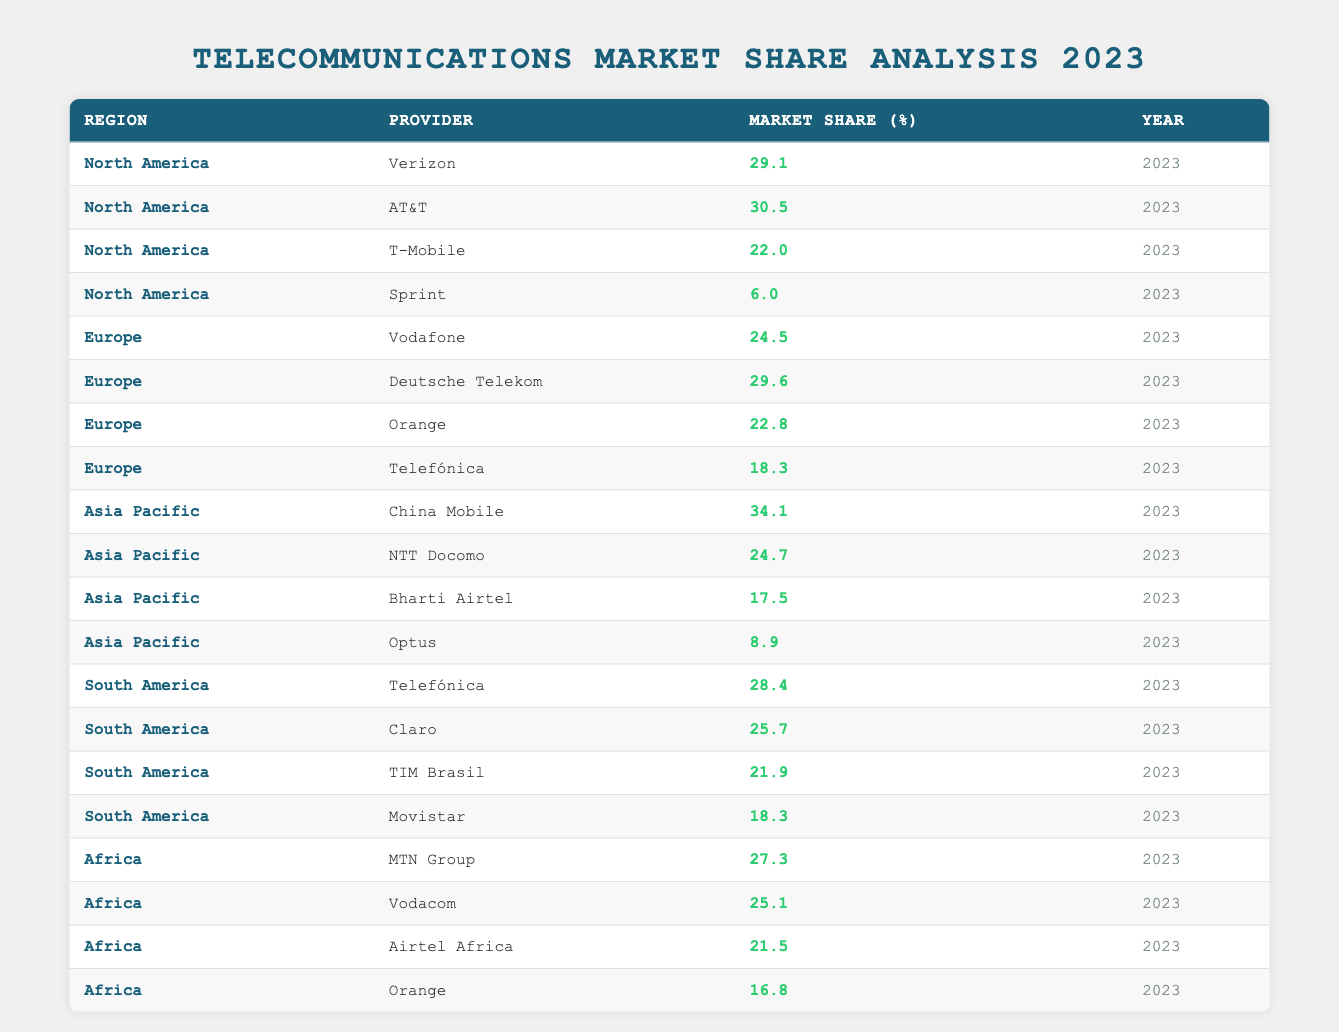What is the market share percentage of AT&T in North America? The table lists AT&T's market share under the North America region for the year 2023 as 30.5%.
Answer: 30.5% Which provider has the highest market share in Asia Pacific? In the Asia Pacific region, the highest market share is held by China Mobile at 34.1%.
Answer: China Mobile What is the average market share of providers in Europe? The total market shares for Europe are 24.5 + 29.6 + 22.8 + 18.3 = 95.2%. There are four providers, so the average is 95.2% / 4 = 23.8%.
Answer: 23.8% Does Sprint have a higher market share than T-Mobile in North America? Sprint's market share is 6.0% and T-Mobile’s is 22.0%, so Sprint has a lower market share compared to T-Mobile.
Answer: No What is the total market share of all providers in South America? The sum of market shares for South America is 28.4 + 25.7 + 21.9 + 18.3 = 94.3%.
Answer: 94.3% Which provider in Africa has the lowest market share percentage? The table shows that Orange has the lowest market share in Africa at 16.8%.
Answer: Orange What is the difference in market share between the highest and lowest provider in North America? The highest is AT&T at 30.5%, and the lowest is Sprint at 6.0%. The difference is 30.5% - 6.0% = 24.5%.
Answer: 24.5% Is Vodafone's market share greater than Deutsche Telekom's? Vodafone has a market share of 24.5%, while Deutsche Telekom has 29.6%. Since 24.5% is less than 29.6%, the statement is false.
Answer: No What percentage of the total telecommunications market in Asia Pacific does NTT Docomo represent? The market shares in Asia Pacific are 34.1, 24.7, 17.5, and 8.9, giving a total of 85.2%. NTT Docomo’s share is 24.7%, thus it represents (24.7 / 85.2) * 100 ≈ 29.0%.
Answer: 29.0% If we consider the top provider in each region, what's the total percentage of their market shares? The top providers are Verizon (29.1, North America), Vodafone (24.5, Europe), China Mobile (34.1, Asia Pacific), Telefónica (28.4, South America), and MTN Group (27.3, Africa). Summing these gives: 29.1 + 24.5 + 34.1 + 28.4 + 27.3 = 143.4%.
Answer: 143.4% 